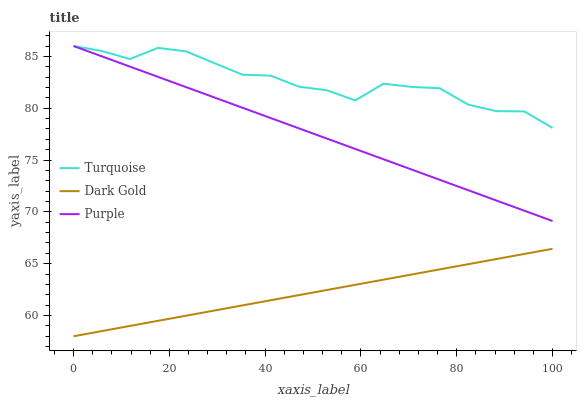Does Dark Gold have the minimum area under the curve?
Answer yes or no. Yes. Does Turquoise have the maximum area under the curve?
Answer yes or no. Yes. Does Turquoise have the minimum area under the curve?
Answer yes or no. No. Does Dark Gold have the maximum area under the curve?
Answer yes or no. No. Is Dark Gold the smoothest?
Answer yes or no. Yes. Is Turquoise the roughest?
Answer yes or no. Yes. Is Turquoise the smoothest?
Answer yes or no. No. Is Dark Gold the roughest?
Answer yes or no. No. Does Dark Gold have the lowest value?
Answer yes or no. Yes. Does Turquoise have the lowest value?
Answer yes or no. No. Does Turquoise have the highest value?
Answer yes or no. Yes. Does Dark Gold have the highest value?
Answer yes or no. No. Is Dark Gold less than Purple?
Answer yes or no. Yes. Is Purple greater than Dark Gold?
Answer yes or no. Yes. Does Purple intersect Turquoise?
Answer yes or no. Yes. Is Purple less than Turquoise?
Answer yes or no. No. Is Purple greater than Turquoise?
Answer yes or no. No. Does Dark Gold intersect Purple?
Answer yes or no. No. 